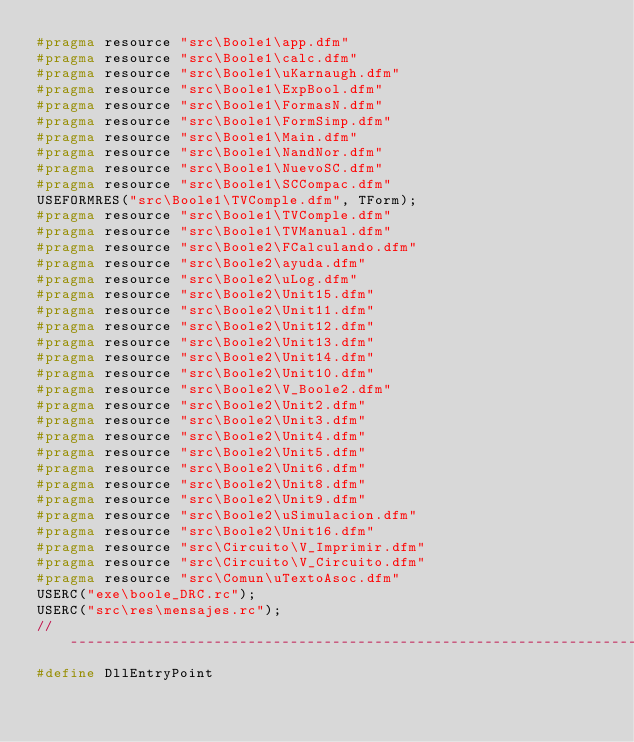<code> <loc_0><loc_0><loc_500><loc_500><_C++_>#pragma resource "src\Boole1\app.dfm"
#pragma resource "src\Boole1\calc.dfm"
#pragma resource "src\Boole1\uKarnaugh.dfm"
#pragma resource "src\Boole1\ExpBool.dfm"
#pragma resource "src\Boole1\FormasN.dfm"
#pragma resource "src\Boole1\FormSimp.dfm"
#pragma resource "src\Boole1\Main.dfm"
#pragma resource "src\Boole1\NandNor.dfm"
#pragma resource "src\Boole1\NuevoSC.dfm"
#pragma resource "src\Boole1\SCCompac.dfm"
USEFORMRES("src\Boole1\TVComple.dfm", TForm);
#pragma resource "src\Boole1\TVComple.dfm"
#pragma resource "src\Boole1\TVManual.dfm"
#pragma resource "src\Boole2\FCalculando.dfm"
#pragma resource "src\Boole2\ayuda.dfm"
#pragma resource "src\Boole2\uLog.dfm"
#pragma resource "src\Boole2\Unit15.dfm"
#pragma resource "src\Boole2\Unit11.dfm"
#pragma resource "src\Boole2\Unit12.dfm"
#pragma resource "src\Boole2\Unit13.dfm"
#pragma resource "src\Boole2\Unit14.dfm"
#pragma resource "src\Boole2\Unit10.dfm"
#pragma resource "src\Boole2\V_Boole2.dfm"
#pragma resource "src\Boole2\Unit2.dfm"
#pragma resource "src\Boole2\Unit3.dfm"
#pragma resource "src\Boole2\Unit4.dfm"
#pragma resource "src\Boole2\Unit5.dfm"
#pragma resource "src\Boole2\Unit6.dfm"
#pragma resource "src\Boole2\Unit8.dfm"
#pragma resource "src\Boole2\Unit9.dfm"
#pragma resource "src\Boole2\uSimulacion.dfm"
#pragma resource "src\Boole2\Unit16.dfm"
#pragma resource "src\Circuito\V_Imprimir.dfm"
#pragma resource "src\Circuito\V_Circuito.dfm"
#pragma resource "src\Comun\uTextoAsoc.dfm"
USERC("exe\boole_DRC.rc");
USERC("src\res\mensajes.rc");
//---------------------------------------------------------------------------
#define DllEntryPoint
</code> 